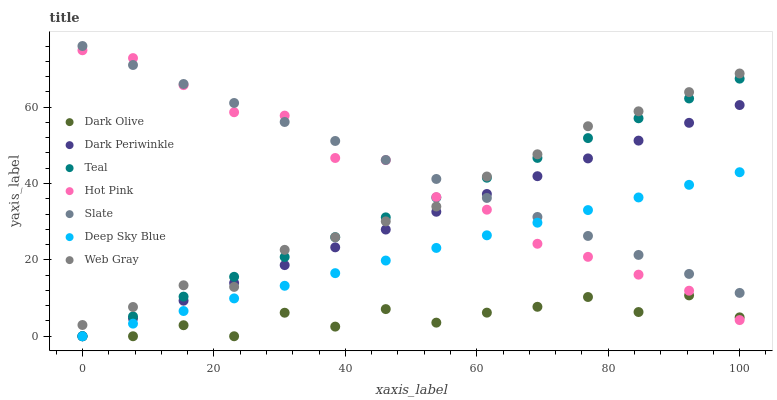Does Dark Olive have the minimum area under the curve?
Answer yes or no. Yes. Does Slate have the maximum area under the curve?
Answer yes or no. Yes. Does Teal have the minimum area under the curve?
Answer yes or no. No. Does Teal have the maximum area under the curve?
Answer yes or no. No. Is Deep Sky Blue the smoothest?
Answer yes or no. Yes. Is Dark Olive the roughest?
Answer yes or no. Yes. Is Teal the smoothest?
Answer yes or no. No. Is Teal the roughest?
Answer yes or no. No. Does Teal have the lowest value?
Answer yes or no. Yes. Does Slate have the lowest value?
Answer yes or no. No. Does Slate have the highest value?
Answer yes or no. Yes. Does Teal have the highest value?
Answer yes or no. No. Is Deep Sky Blue less than Web Gray?
Answer yes or no. Yes. Is Web Gray greater than Deep Sky Blue?
Answer yes or no. Yes. Does Dark Periwinkle intersect Dark Olive?
Answer yes or no. Yes. Is Dark Periwinkle less than Dark Olive?
Answer yes or no. No. Is Dark Periwinkle greater than Dark Olive?
Answer yes or no. No. Does Deep Sky Blue intersect Web Gray?
Answer yes or no. No. 